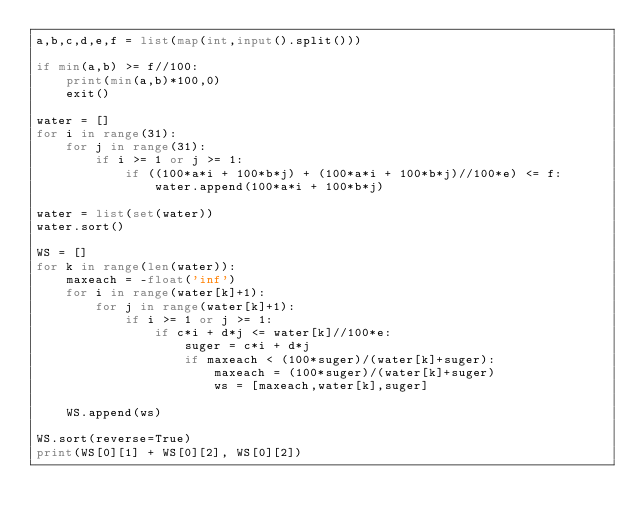<code> <loc_0><loc_0><loc_500><loc_500><_Python_>a,b,c,d,e,f = list(map(int,input().split()))

if min(a,b) >= f//100:
    print(min(a,b)*100,0)
    exit()

water = []
for i in range(31):
    for j in range(31):
        if i >= 1 or j >= 1:
            if ((100*a*i + 100*b*j) + (100*a*i + 100*b*j)//100*e) <= f:
                water.append(100*a*i + 100*b*j)
                
water = list(set(water))
water.sort()

WS = []
for k in range(len(water)):
    maxeach = -float('inf')
    for i in range(water[k]+1):
        for j in range(water[k]+1):
            if i >= 1 or j >= 1:
                if c*i + d*j <= water[k]//100*e:
                    suger = c*i + d*j
                    if maxeach < (100*suger)/(water[k]+suger):
                        maxeach = (100*suger)/(water[k]+suger)
                        ws = [maxeach,water[k],suger]

    WS.append(ws)
                    
WS.sort(reverse=True)
print(WS[0][1] + WS[0][2], WS[0][2])</code> 